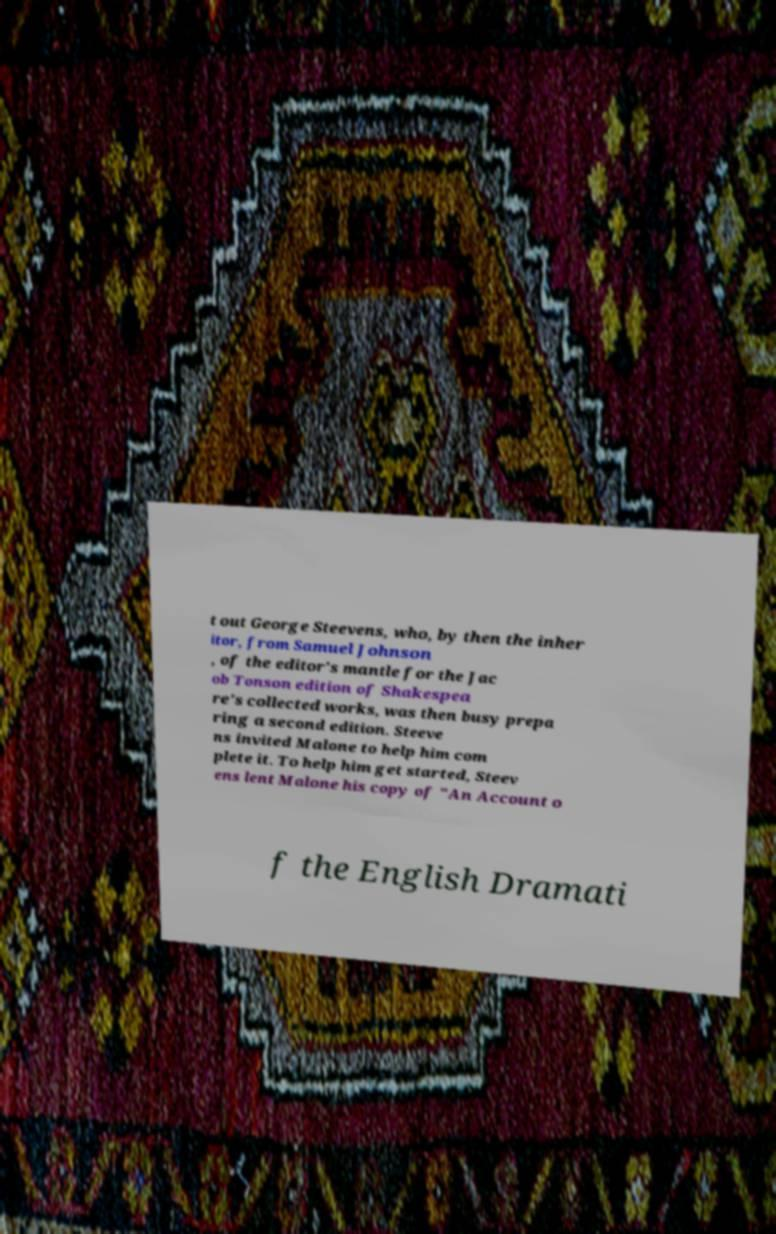Please read and relay the text visible in this image. What does it say? t out George Steevens, who, by then the inher itor, from Samuel Johnson , of the editor's mantle for the Jac ob Tonson edition of Shakespea re's collected works, was then busy prepa ring a second edition. Steeve ns invited Malone to help him com plete it. To help him get started, Steev ens lent Malone his copy of "An Account o f the English Dramati 